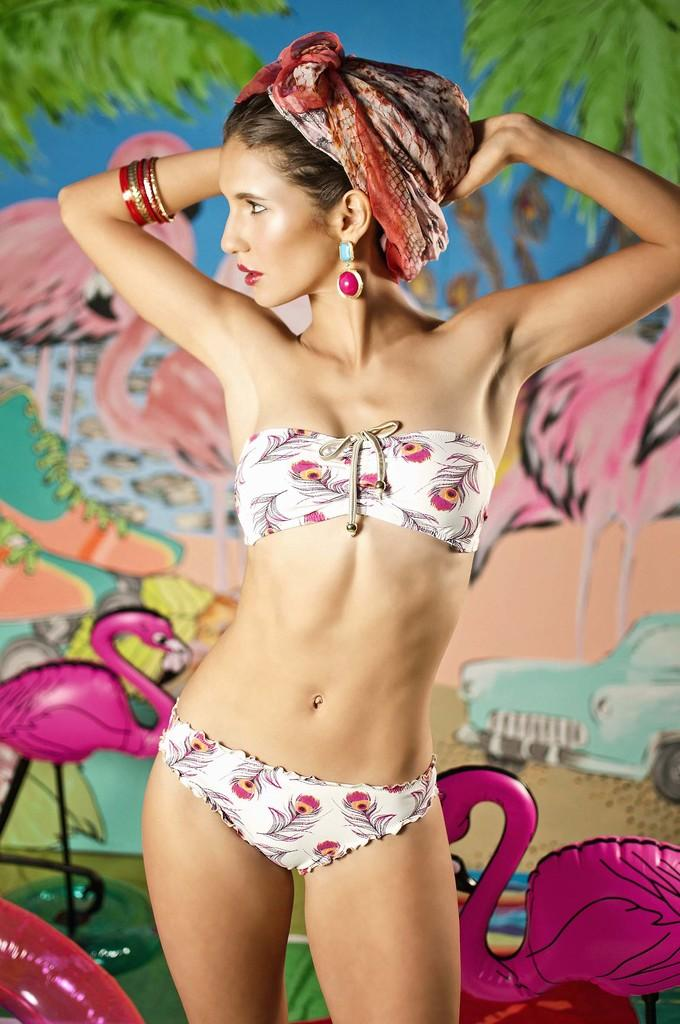What is the woman in the image doing? The woman is standing in the image. Can you describe the woman's appearance? The woman has a cloth on her head. What can be seen in the background of the image? There are birds, toys, and pictures of birds on the wall in the background. Can you describe the pictures on the wall? There is a picture of a car and a picture of birds on the wall, both of which have water visible in the picture. What type of coil is being used by the woman to hold her hair in the image? There is no coil visible in the image; the woman has a cloth on her head. How many balls are being juggled by the birds in the background of the image? There are no balls or juggling depicted in the image; the birds are simply present in the background. 